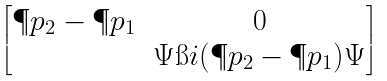Convert formula to latex. <formula><loc_0><loc_0><loc_500><loc_500>\begin{bmatrix} \P p _ { 2 } - \P p _ { 1 } & 0 \\ & \Psi \i i ( \P p _ { 2 } - \P p _ { 1 } ) \Psi \\ \end{bmatrix}</formula> 